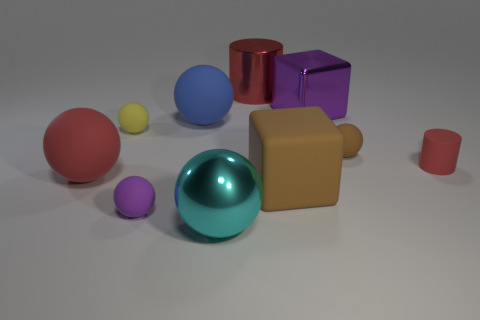Can you describe the shapes and colors present in the image? The image showcases a variety of geometric shapes including spheres, a cube, and cylinders in an array of colors such as red, blue, purple, and beige. 